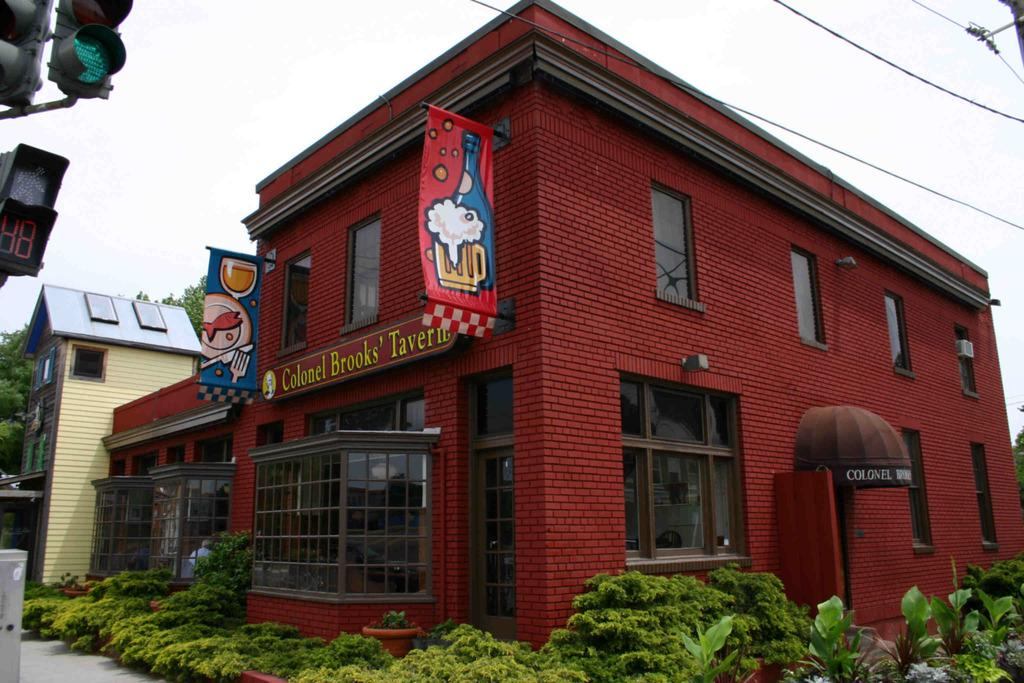What is located in the center of the image? There are buildings in the center of the image. What can be seen hanging or attached in the image? Banners are present in the image. Where is the traffic light located in the image? The traffic light is on the left side of the image. What type of vegetation is visible at the bottom of the image? Bushes are visible at the bottom of the image. What is present at the top of the image, besides the sky? Wires are present at the top of the image. Can you hear the bell ringing in the image? There is no bell present in the image, so it cannot be heard. What type of food is being bitten in the image? There is no food or biting action present in the image. 